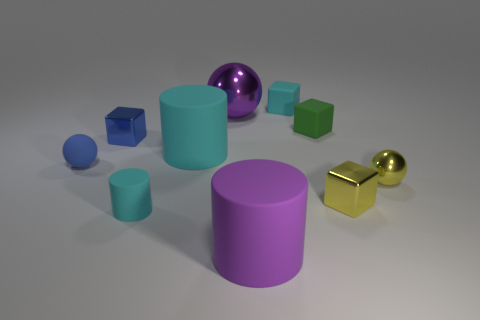Is there a matte object of the same color as the small cylinder?
Offer a very short reply. Yes. How big is the green matte thing?
Ensure brevity in your answer.  Small. Are the purple sphere and the purple cylinder made of the same material?
Provide a succinct answer. No. What number of metallic things are to the right of the small cyan object that is in front of the small cyan matte thing that is behind the yellow cube?
Offer a terse response. 3. What shape is the rubber thing to the left of the tiny cyan cylinder?
Your response must be concise. Sphere. How many other things are there of the same material as the tiny cyan cube?
Your answer should be very brief. 5. Are there fewer tiny metallic spheres that are on the left side of the yellow sphere than tiny cyan things on the left side of the purple cylinder?
Provide a short and direct response. Yes. What is the color of the other small rubber object that is the same shape as the tiny green rubber object?
Ensure brevity in your answer.  Cyan. Do the metallic sphere that is behind the green matte block and the blue metal cube have the same size?
Keep it short and to the point. No. Are there fewer small blue matte things that are to the right of the tiny cyan cylinder than purple matte objects?
Your answer should be compact. Yes. 